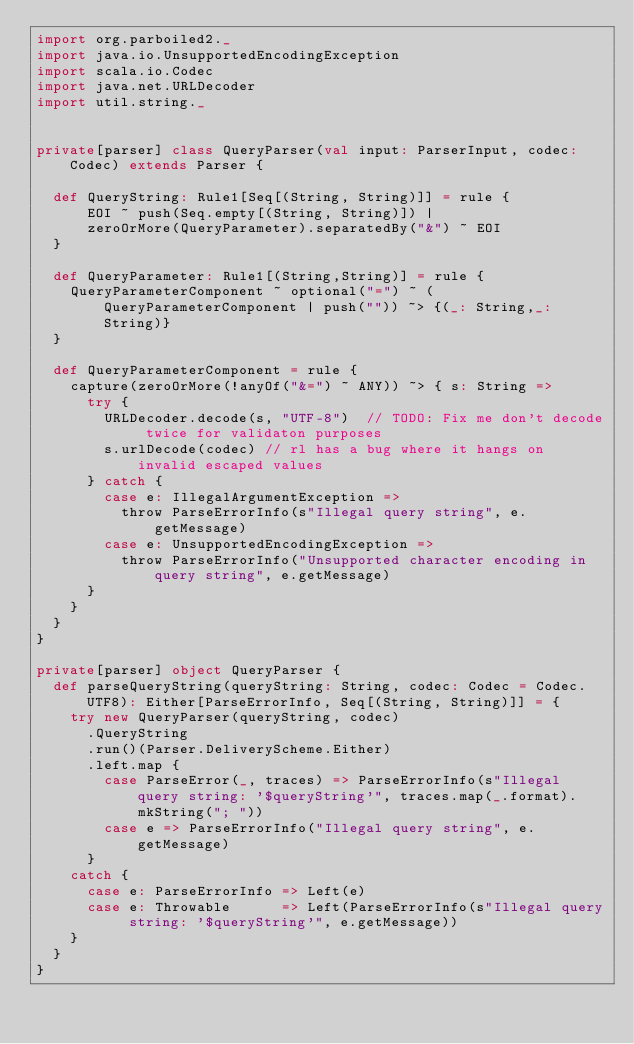Convert code to text. <code><loc_0><loc_0><loc_500><loc_500><_Scala_>import org.parboiled2._
import java.io.UnsupportedEncodingException
import scala.io.Codec
import java.net.URLDecoder
import util.string._


private[parser] class QueryParser(val input: ParserInput, codec: Codec) extends Parser {

  def QueryString: Rule1[Seq[(String, String)]] = rule {
      EOI ~ push(Seq.empty[(String, String)]) |
      zeroOrMore(QueryParameter).separatedBy("&") ~ EOI
  }

  def QueryParameter: Rule1[(String,String)] = rule {
    QueryParameterComponent ~ optional("=") ~ (QueryParameterComponent | push("")) ~> {(_: String,_: String)}
  }

  def QueryParameterComponent = rule {
    capture(zeroOrMore(!anyOf("&=") ~ ANY)) ~> { s: String =>
      try {
        URLDecoder.decode(s, "UTF-8")  // TODO: Fix me don't decode twice for validaton purposes
        s.urlDecode(codec) // rl has a bug where it hangs on invalid escaped values
      } catch {
        case e: IllegalArgumentException =>
          throw ParseErrorInfo(s"Illegal query string", e.getMessage)
        case e: UnsupportedEncodingException =>
          throw ParseErrorInfo("Unsupported character encoding in query string", e.getMessage)
      }
    }
  }
}

private[parser] object QueryParser {
  def parseQueryString(queryString: String, codec: Codec = Codec.UTF8): Either[ParseErrorInfo, Seq[(String, String)]] = {
    try new QueryParser(queryString, codec)
      .QueryString
      .run()(Parser.DeliveryScheme.Either)
      .left.map {
        case ParseError(_, traces) => ParseErrorInfo(s"Illegal query string: '$queryString'", traces.map(_.format).mkString("; "))
        case e => ParseErrorInfo("Illegal query string", e.getMessage)
      }
    catch {
      case e: ParseErrorInfo => Left(e)
      case e: Throwable      => Left(ParseErrorInfo(s"Illegal query string: '$queryString'", e.getMessage))
    }
  }
}</code> 